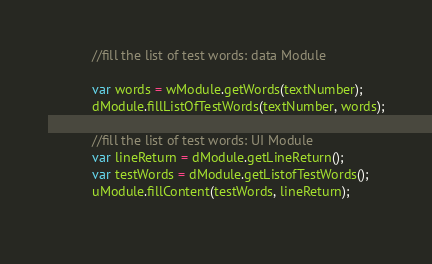<code> <loc_0><loc_0><loc_500><loc_500><_JavaScript_>            //fill the list of test words: data Module
          
            var words = wModule.getWords(textNumber);
            dModule.fillListOfTestWords(textNumber, words);
            
            //fill the list of test words: UI Module
            var lineReturn = dModule.getLineReturn();
            var testWords = dModule.getListofTestWords();
            uModule.fillContent(testWords, lineReturn);
            </code> 